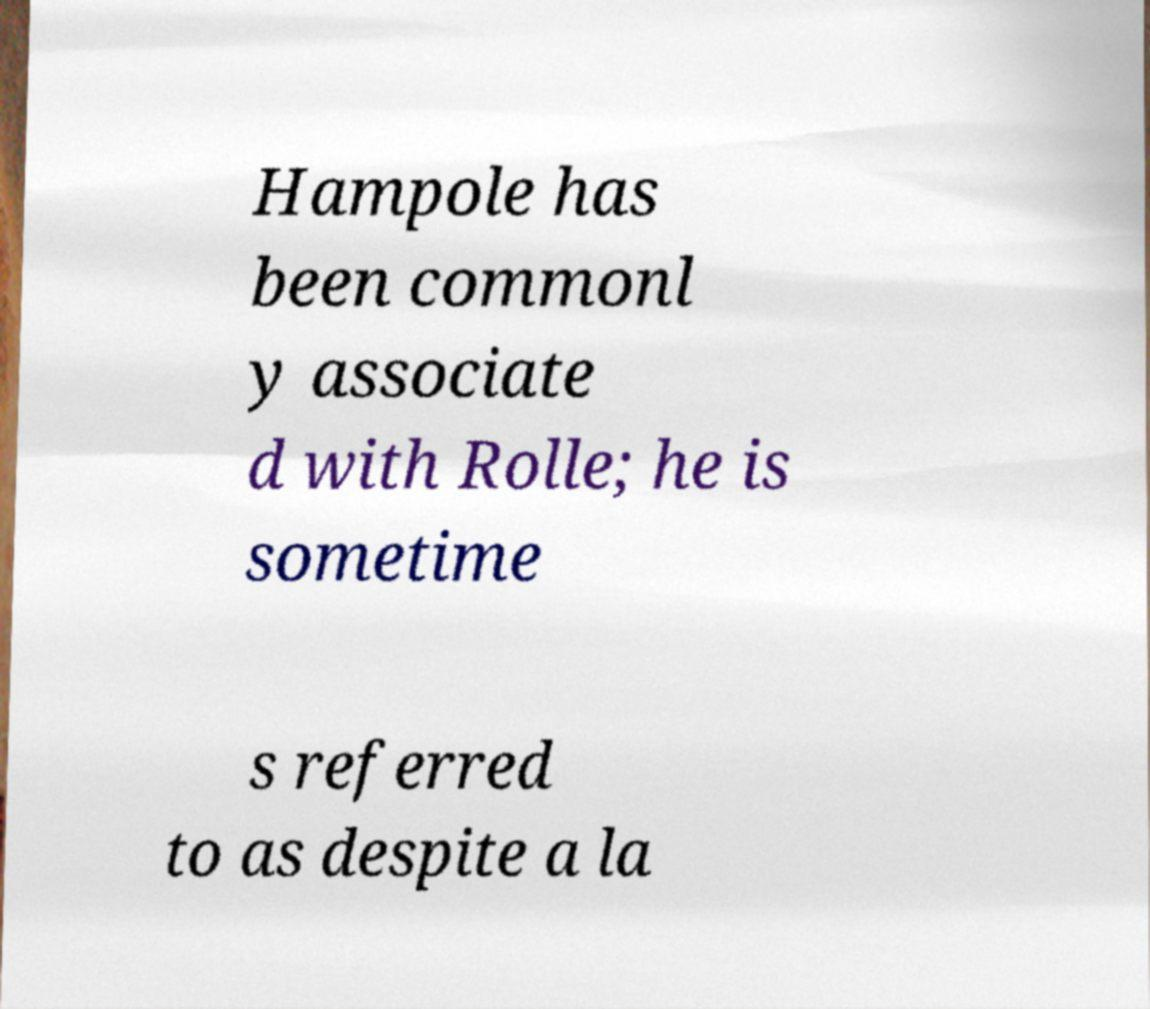Can you accurately transcribe the text from the provided image for me? Hampole has been commonl y associate d with Rolle; he is sometime s referred to as despite a la 